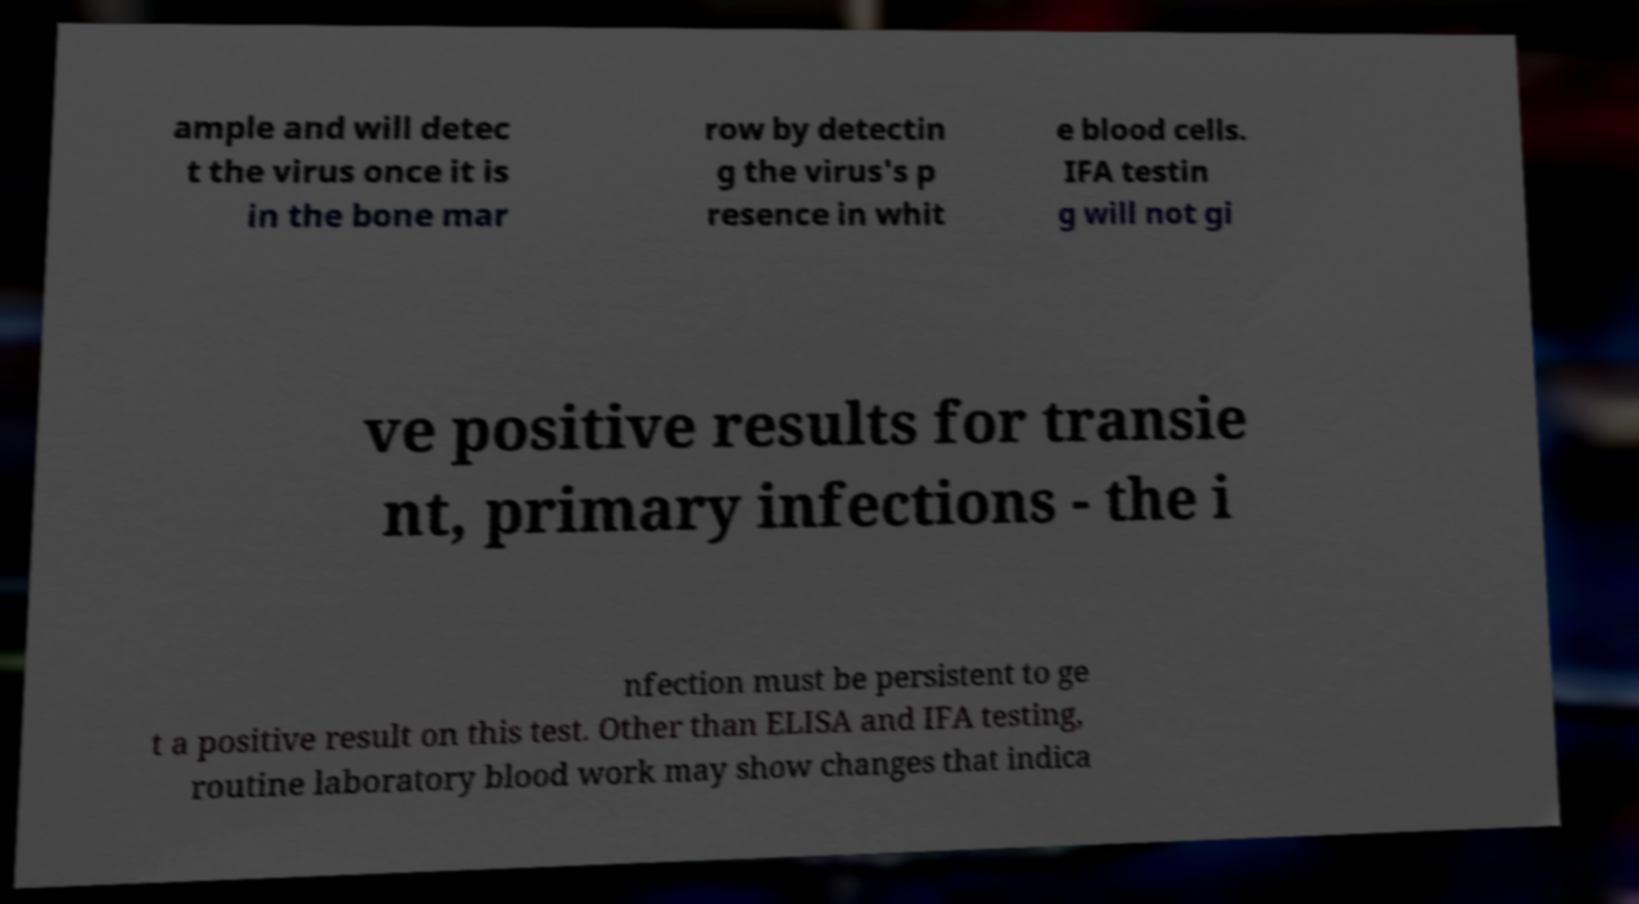What messages or text are displayed in this image? I need them in a readable, typed format. ample and will detec t the virus once it is in the bone mar row by detectin g the virus's p resence in whit e blood cells. IFA testin g will not gi ve positive results for transie nt, primary infections - the i nfection must be persistent to ge t a positive result on this test. Other than ELISA and IFA testing, routine laboratory blood work may show changes that indica 